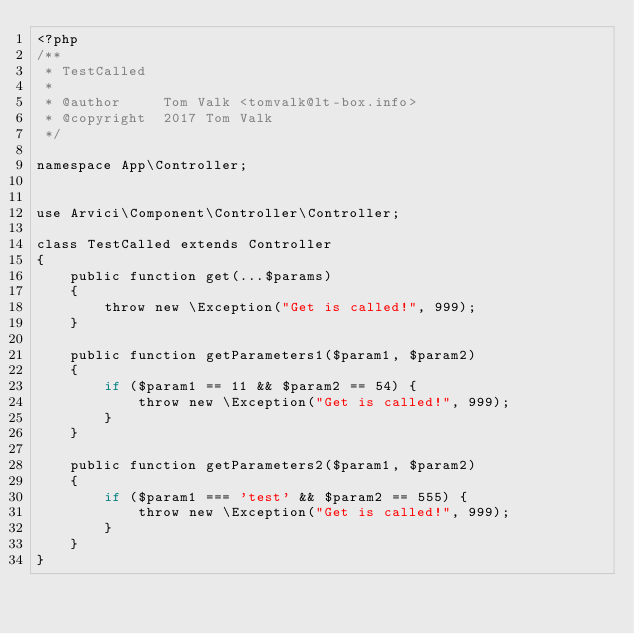<code> <loc_0><loc_0><loc_500><loc_500><_PHP_><?php
/**
 * TestCalled
 *
 * @author     Tom Valk <tomvalk@lt-box.info>
 * @copyright  2017 Tom Valk
 */

namespace App\Controller;


use Arvici\Component\Controller\Controller;

class TestCalled extends Controller
{
    public function get(...$params)
    {
        throw new \Exception("Get is called!", 999);
    }

    public function getParameters1($param1, $param2)
    {
        if ($param1 == 11 && $param2 == 54) {
            throw new \Exception("Get is called!", 999);
        }
    }

    public function getParameters2($param1, $param2)
    {
        if ($param1 === 'test' && $param2 == 555) {
            throw new \Exception("Get is called!", 999);
        }
    }
}
</code> 